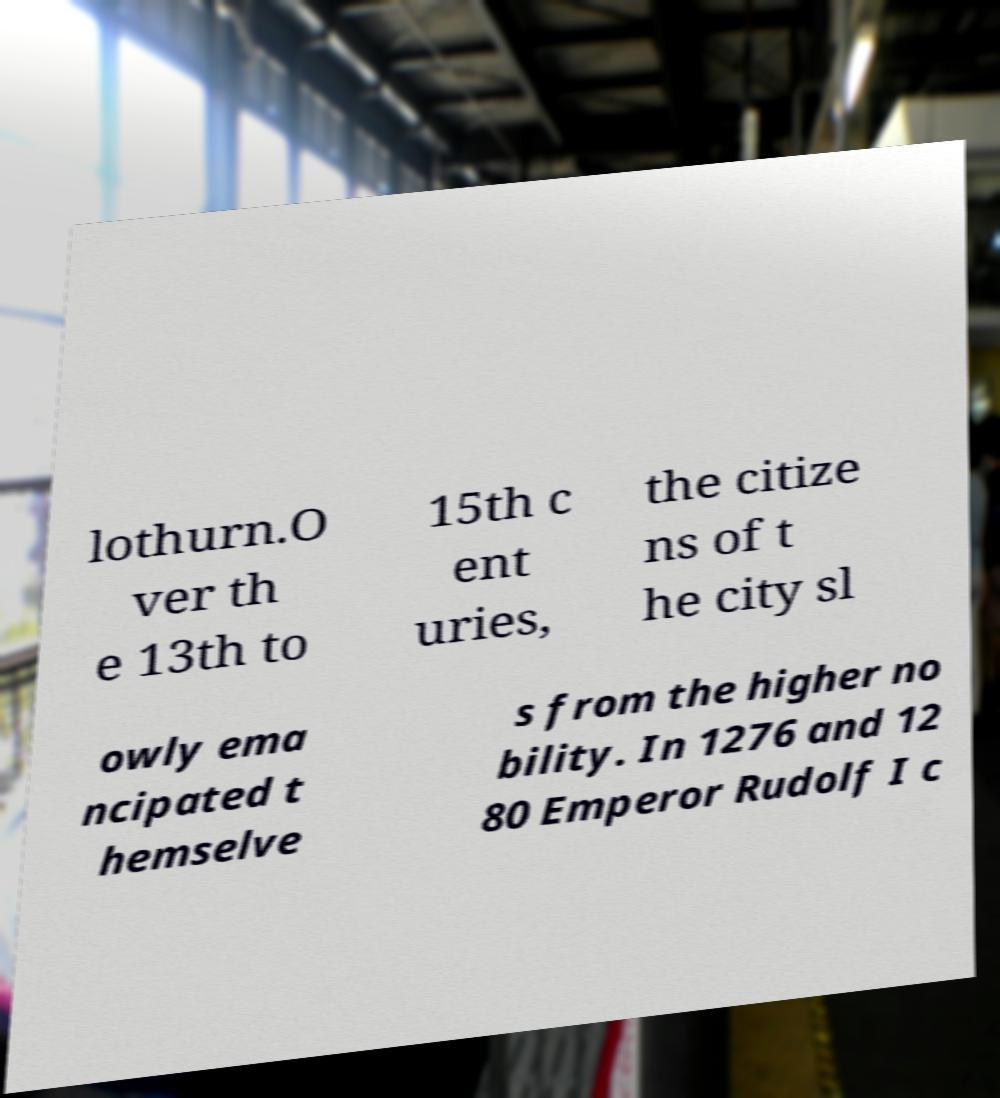There's text embedded in this image that I need extracted. Can you transcribe it verbatim? lothurn.O ver th e 13th to 15th c ent uries, the citize ns of t he city sl owly ema ncipated t hemselve s from the higher no bility. In 1276 and 12 80 Emperor Rudolf I c 